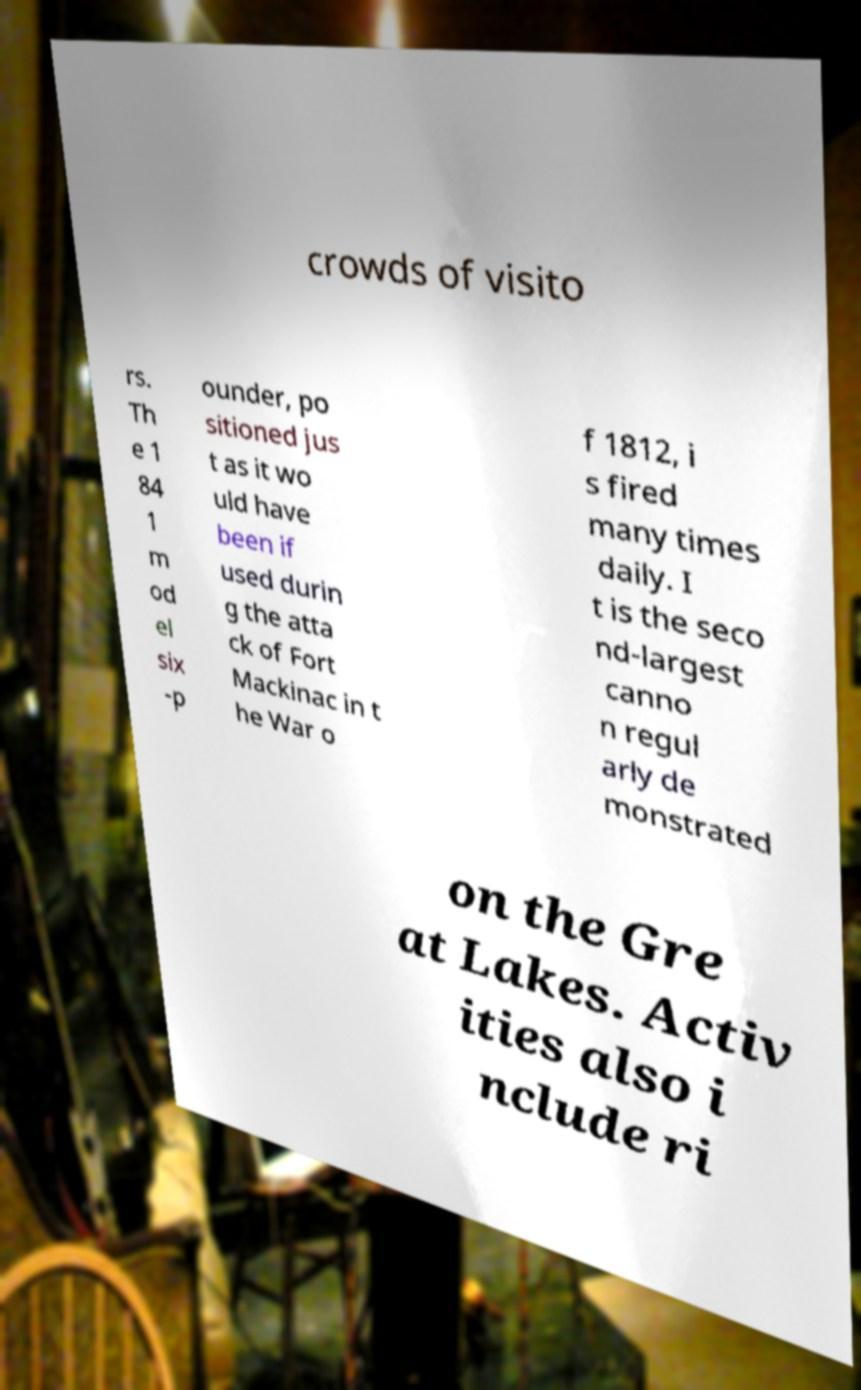For documentation purposes, I need the text within this image transcribed. Could you provide that? crowds of visito rs. Th e 1 84 1 m od el six -p ounder, po sitioned jus t as it wo uld have been if used durin g the atta ck of Fort Mackinac in t he War o f 1812, i s fired many times daily. I t is the seco nd-largest canno n regul arly de monstrated on the Gre at Lakes. Activ ities also i nclude ri 